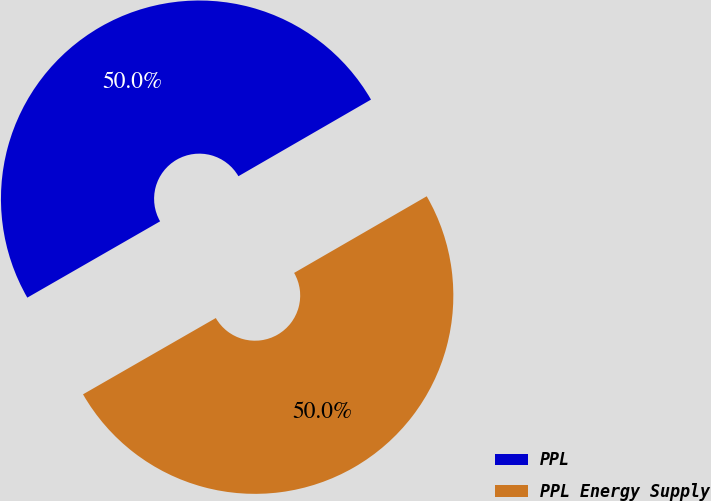Convert chart to OTSL. <chart><loc_0><loc_0><loc_500><loc_500><pie_chart><fcel>PPL<fcel>PPL Energy Supply<nl><fcel>49.96%<fcel>50.04%<nl></chart> 